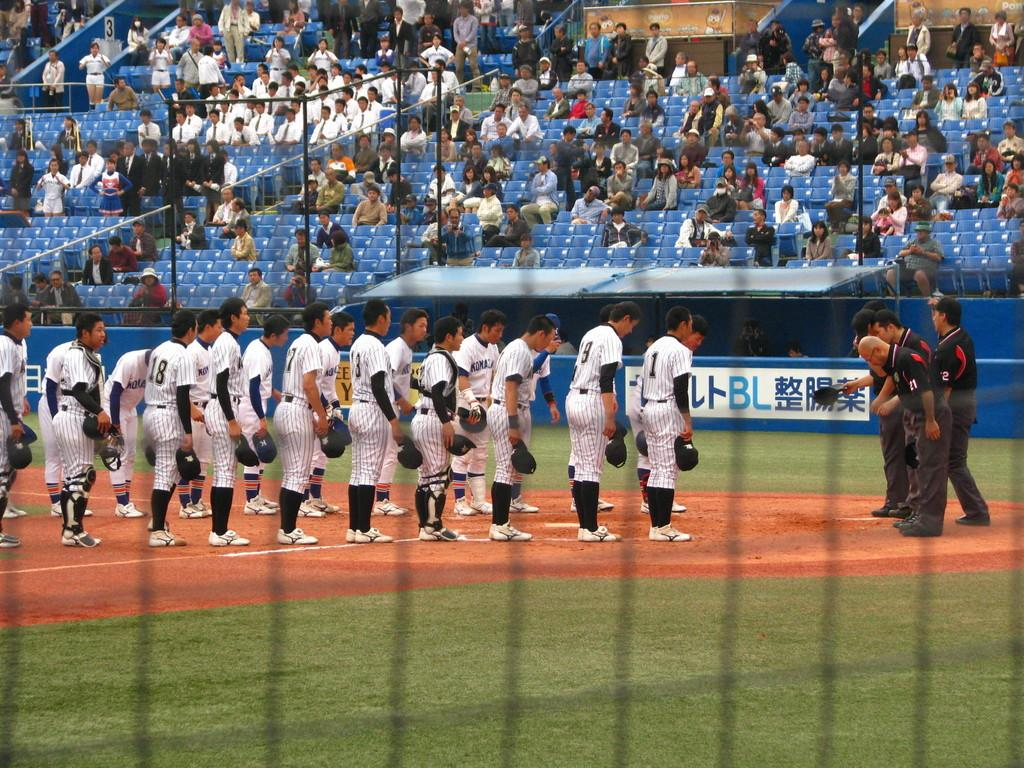<image>
Create a compact narrative representing the image presented. Player number 1 is at the end of the line of baseball players. 